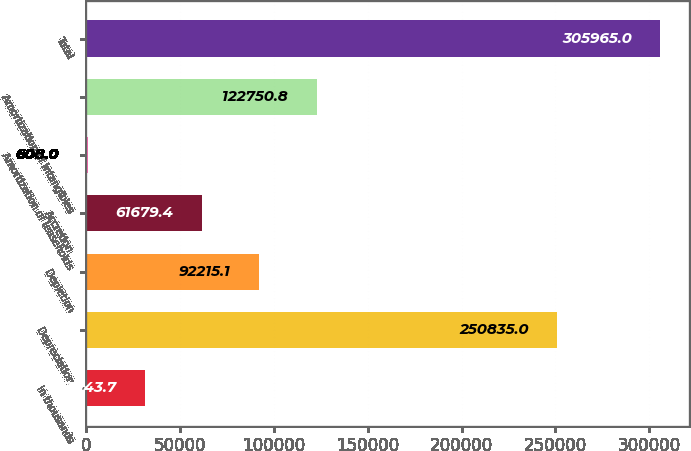Convert chart. <chart><loc_0><loc_0><loc_500><loc_500><bar_chart><fcel>in thousands<fcel>Depreciation<fcel>Depletion<fcel>Accretion<fcel>Amortization of leaseholds<fcel>Amortization of intangibles<fcel>Total<nl><fcel>31143.7<fcel>250835<fcel>92215.1<fcel>61679.4<fcel>608<fcel>122751<fcel>305965<nl></chart> 